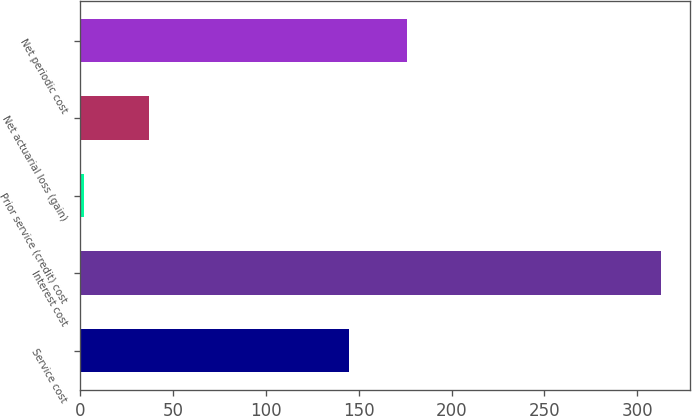Convert chart. <chart><loc_0><loc_0><loc_500><loc_500><bar_chart><fcel>Service cost<fcel>Interest cost<fcel>Prior service (credit) cost<fcel>Net actuarial loss (gain)<fcel>Net periodic cost<nl><fcel>145<fcel>313<fcel>2<fcel>37<fcel>176.1<nl></chart> 